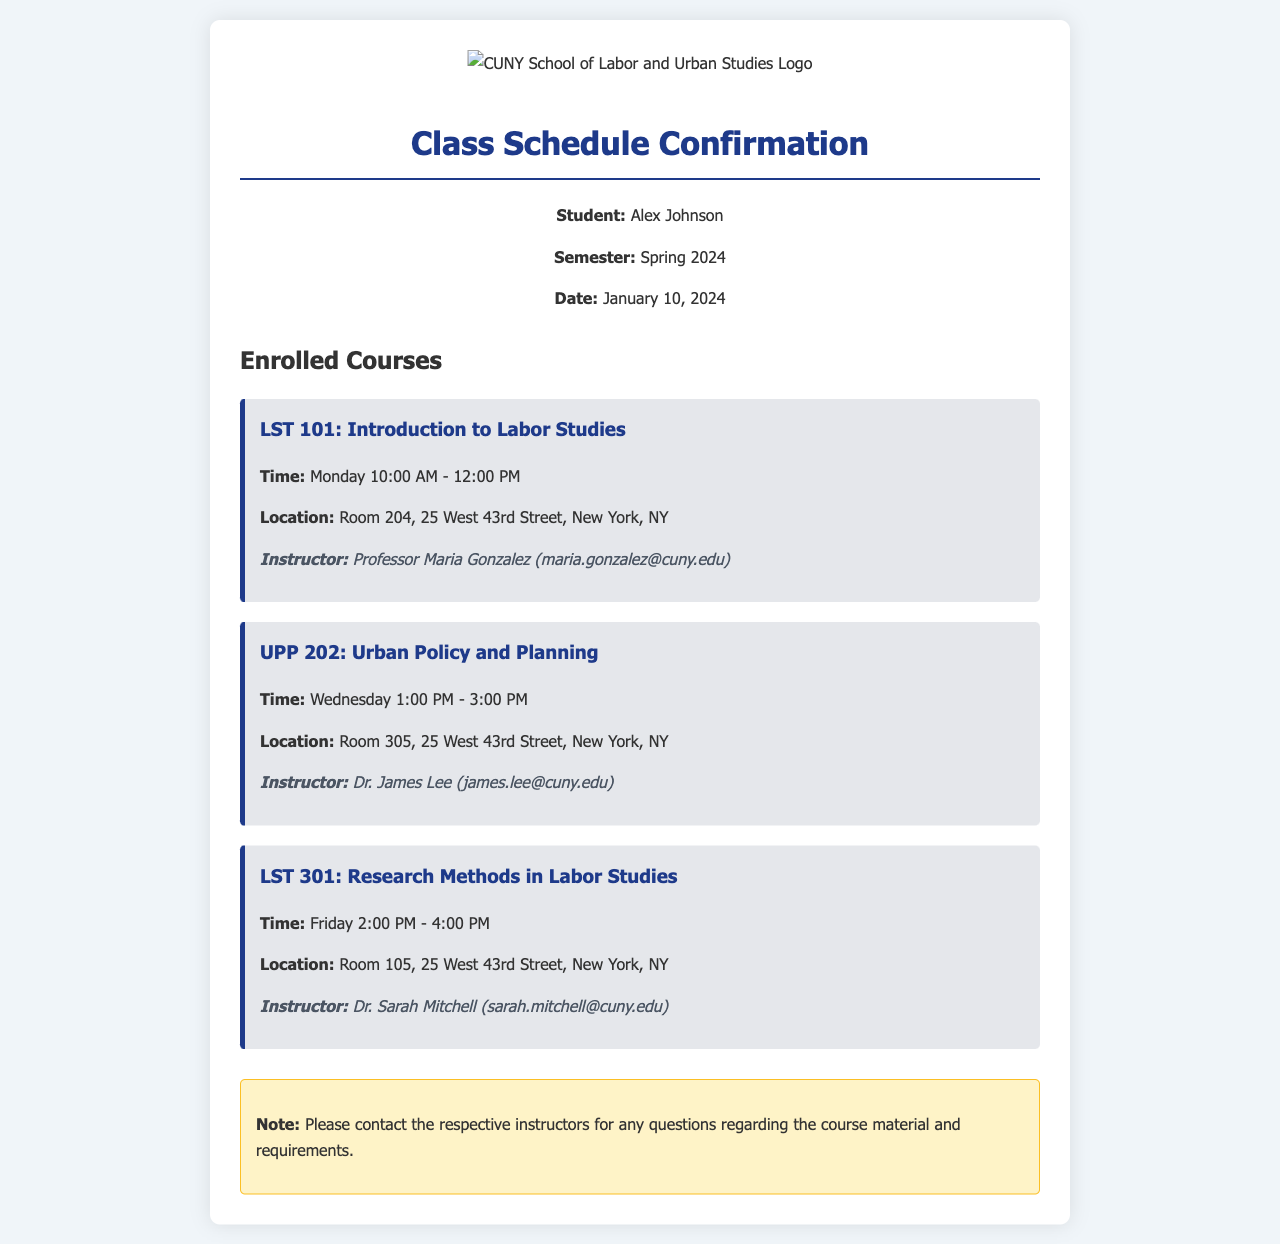What is the name of the student? The name of the student is mentioned in the header of the document.
Answer: Alex Johnson What is the semester referred to in the document? The semester is specified right after the student's name.
Answer: Spring 2024 What day and time does LST 101 meet? The meeting time for LST 101 is included in its detailed section.
Answer: Monday 10:00 AM - 12:00 PM Who is the instructor for UPP 202? The instructor's name for UPP 202 is listed under that course's details.
Answer: Dr. James Lee Where is LST 301 held? The location of LST 301 is provided in its course information section.
Answer: Room 105, 25 West 43rd Street, New York, NY How many courses are listed in the document? The number of courses can be counted from the section labeled "Enrolled Courses."
Answer: Three What is the contact email for Professor Maria Gonzalez? The contact email for Professor Maria Gonzalez is found in her course details.
Answer: maria.gonzalez@cuny.edu What is the main purpose of the note at the end of the document? The note provides specific instructions or advice regarding course inquiries.
Answer: Contact instructors for questions regarding course material 